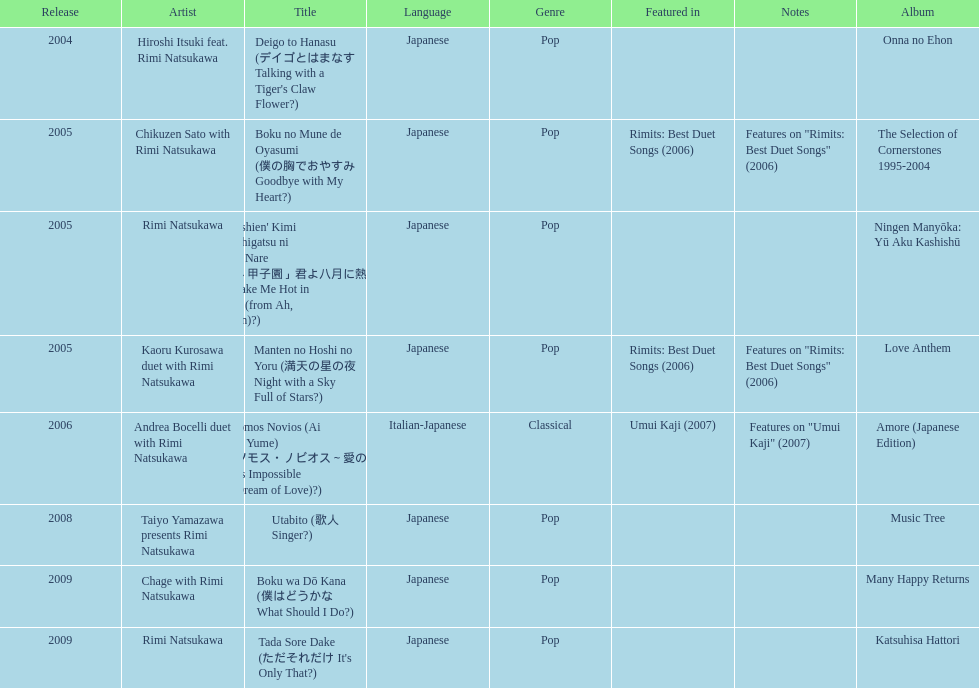How many other appearance did this artist make in 2005? 3. 